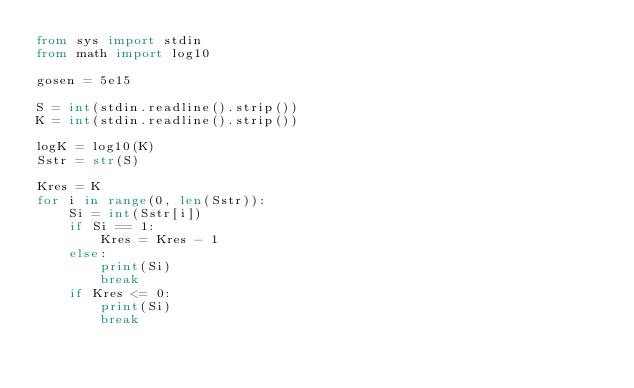Convert code to text. <code><loc_0><loc_0><loc_500><loc_500><_Python_>from sys import stdin
from math import log10

gosen = 5e15

S = int(stdin.readline().strip())
K = int(stdin.readline().strip())

logK = log10(K)
Sstr = str(S)

Kres = K
for i in range(0, len(Sstr)):
    Si = int(Sstr[i])
    if Si == 1:
        Kres = Kres - 1
    else:
        print(Si)
        break
    if Kres <= 0:
        print(Si)
        break


</code> 